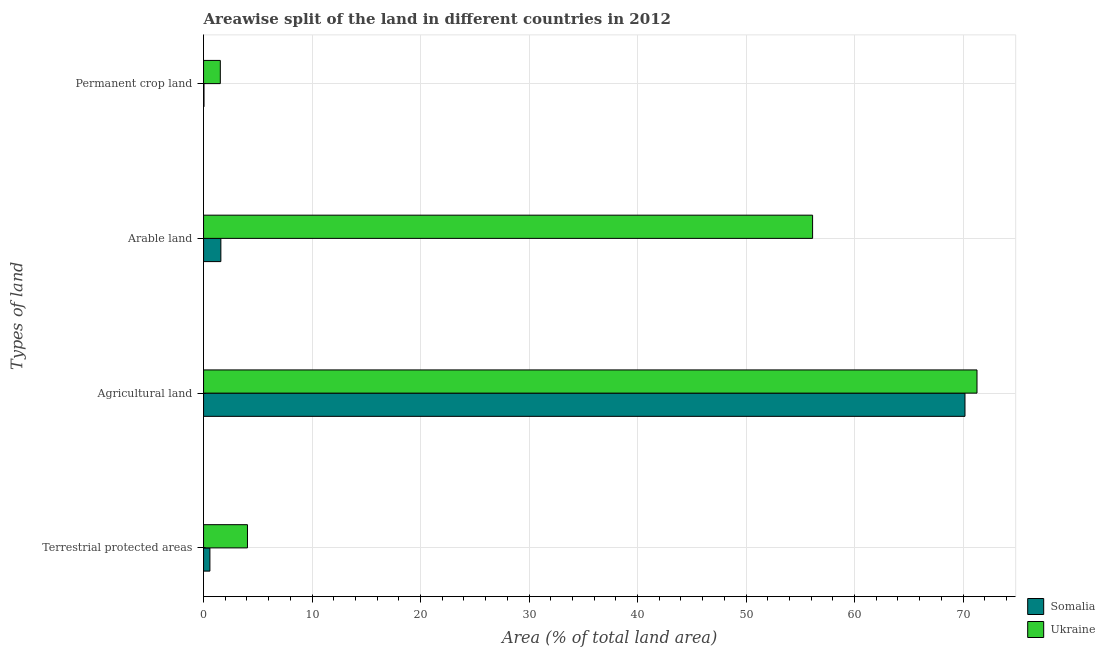How many groups of bars are there?
Your answer should be compact. 4. How many bars are there on the 1st tick from the top?
Make the answer very short. 2. What is the label of the 3rd group of bars from the top?
Keep it short and to the point. Agricultural land. What is the percentage of area under permanent crop land in Somalia?
Provide a short and direct response. 0.04. Across all countries, what is the maximum percentage of area under arable land?
Your response must be concise. 56.13. Across all countries, what is the minimum percentage of area under permanent crop land?
Provide a short and direct response. 0.04. In which country was the percentage of land under terrestrial protection maximum?
Give a very brief answer. Ukraine. In which country was the percentage of area under permanent crop land minimum?
Provide a succinct answer. Somalia. What is the total percentage of area under permanent crop land in the graph?
Provide a short and direct response. 1.58. What is the difference between the percentage of area under arable land in Ukraine and that in Somalia?
Your answer should be compact. 54.54. What is the difference between the percentage of area under agricultural land in Somalia and the percentage of area under permanent crop land in Ukraine?
Offer a terse response. 68.63. What is the average percentage of area under agricultural land per country?
Keep it short and to the point. 70.73. What is the difference between the percentage of area under permanent crop land and percentage of land under terrestrial protection in Somalia?
Offer a very short reply. -0.54. What is the ratio of the percentage of area under permanent crop land in Ukraine to that in Somalia?
Offer a very short reply. 38.72. Is the percentage of area under arable land in Ukraine less than that in Somalia?
Provide a succinct answer. No. What is the difference between the highest and the second highest percentage of land under terrestrial protection?
Give a very brief answer. 3.46. What is the difference between the highest and the lowest percentage of area under agricultural land?
Provide a short and direct response. 1.11. Is the sum of the percentage of area under agricultural land in Somalia and Ukraine greater than the maximum percentage of land under terrestrial protection across all countries?
Make the answer very short. Yes. Is it the case that in every country, the sum of the percentage of area under arable land and percentage of land under terrestrial protection is greater than the sum of percentage of area under permanent crop land and percentage of area under agricultural land?
Offer a terse response. Yes. What does the 2nd bar from the top in Permanent crop land represents?
Your response must be concise. Somalia. What does the 2nd bar from the bottom in Terrestrial protected areas represents?
Offer a terse response. Ukraine. Is it the case that in every country, the sum of the percentage of land under terrestrial protection and percentage of area under agricultural land is greater than the percentage of area under arable land?
Your response must be concise. Yes. How many countries are there in the graph?
Your answer should be very brief. 2. What is the difference between two consecutive major ticks on the X-axis?
Offer a terse response. 10. Are the values on the major ticks of X-axis written in scientific E-notation?
Keep it short and to the point. No. Does the graph contain grids?
Keep it short and to the point. Yes. Where does the legend appear in the graph?
Give a very brief answer. Bottom right. How are the legend labels stacked?
Keep it short and to the point. Vertical. What is the title of the graph?
Provide a short and direct response. Areawise split of the land in different countries in 2012. What is the label or title of the X-axis?
Your answer should be compact. Area (% of total land area). What is the label or title of the Y-axis?
Provide a succinct answer. Types of land. What is the Area (% of total land area) in Somalia in Terrestrial protected areas?
Your answer should be very brief. 0.58. What is the Area (% of total land area) of Ukraine in Terrestrial protected areas?
Your response must be concise. 4.05. What is the Area (% of total land area) of Somalia in Agricultural land?
Your response must be concise. 70.18. What is the Area (% of total land area) of Ukraine in Agricultural land?
Make the answer very short. 71.29. What is the Area (% of total land area) of Somalia in Arable land?
Your response must be concise. 1.59. What is the Area (% of total land area) of Ukraine in Arable land?
Your answer should be compact. 56.13. What is the Area (% of total land area) in Somalia in Permanent crop land?
Offer a terse response. 0.04. What is the Area (% of total land area) in Ukraine in Permanent crop land?
Your answer should be compact. 1.54. Across all Types of land, what is the maximum Area (% of total land area) of Somalia?
Your answer should be very brief. 70.18. Across all Types of land, what is the maximum Area (% of total land area) of Ukraine?
Ensure brevity in your answer.  71.29. Across all Types of land, what is the minimum Area (% of total land area) of Somalia?
Give a very brief answer. 0.04. Across all Types of land, what is the minimum Area (% of total land area) in Ukraine?
Offer a terse response. 1.54. What is the total Area (% of total land area) of Somalia in the graph?
Ensure brevity in your answer.  72.4. What is the total Area (% of total land area) of Ukraine in the graph?
Ensure brevity in your answer.  133.01. What is the difference between the Area (% of total land area) in Somalia in Terrestrial protected areas and that in Agricultural land?
Give a very brief answer. -69.59. What is the difference between the Area (% of total land area) of Ukraine in Terrestrial protected areas and that in Agricultural land?
Your answer should be compact. -67.24. What is the difference between the Area (% of total land area) in Somalia in Terrestrial protected areas and that in Arable land?
Offer a very short reply. -1.01. What is the difference between the Area (% of total land area) of Ukraine in Terrestrial protected areas and that in Arable land?
Your response must be concise. -52.08. What is the difference between the Area (% of total land area) of Somalia in Terrestrial protected areas and that in Permanent crop land?
Ensure brevity in your answer.  0.54. What is the difference between the Area (% of total land area) in Ukraine in Terrestrial protected areas and that in Permanent crop land?
Your answer should be very brief. 2.5. What is the difference between the Area (% of total land area) of Somalia in Agricultural land and that in Arable land?
Provide a succinct answer. 68.58. What is the difference between the Area (% of total land area) in Ukraine in Agricultural land and that in Arable land?
Offer a terse response. 15.15. What is the difference between the Area (% of total land area) of Somalia in Agricultural land and that in Permanent crop land?
Your response must be concise. 70.14. What is the difference between the Area (% of total land area) of Ukraine in Agricultural land and that in Permanent crop land?
Keep it short and to the point. 69.74. What is the difference between the Area (% of total land area) of Somalia in Arable land and that in Permanent crop land?
Give a very brief answer. 1.55. What is the difference between the Area (% of total land area) of Ukraine in Arable land and that in Permanent crop land?
Give a very brief answer. 54.59. What is the difference between the Area (% of total land area) in Somalia in Terrestrial protected areas and the Area (% of total land area) in Ukraine in Agricultural land?
Your answer should be very brief. -70.7. What is the difference between the Area (% of total land area) of Somalia in Terrestrial protected areas and the Area (% of total land area) of Ukraine in Arable land?
Make the answer very short. -55.55. What is the difference between the Area (% of total land area) of Somalia in Terrestrial protected areas and the Area (% of total land area) of Ukraine in Permanent crop land?
Your answer should be very brief. -0.96. What is the difference between the Area (% of total land area) of Somalia in Agricultural land and the Area (% of total land area) of Ukraine in Arable land?
Keep it short and to the point. 14.05. What is the difference between the Area (% of total land area) of Somalia in Agricultural land and the Area (% of total land area) of Ukraine in Permanent crop land?
Your answer should be compact. 68.63. What is the difference between the Area (% of total land area) of Somalia in Arable land and the Area (% of total land area) of Ukraine in Permanent crop land?
Provide a short and direct response. 0.05. What is the average Area (% of total land area) in Somalia per Types of land?
Offer a terse response. 18.1. What is the average Area (% of total land area) in Ukraine per Types of land?
Keep it short and to the point. 33.25. What is the difference between the Area (% of total land area) in Somalia and Area (% of total land area) in Ukraine in Terrestrial protected areas?
Keep it short and to the point. -3.46. What is the difference between the Area (% of total land area) in Somalia and Area (% of total land area) in Ukraine in Agricultural land?
Your answer should be very brief. -1.11. What is the difference between the Area (% of total land area) of Somalia and Area (% of total land area) of Ukraine in Arable land?
Make the answer very short. -54.54. What is the difference between the Area (% of total land area) in Somalia and Area (% of total land area) in Ukraine in Permanent crop land?
Your answer should be compact. -1.5. What is the ratio of the Area (% of total land area) of Somalia in Terrestrial protected areas to that in Agricultural land?
Provide a short and direct response. 0.01. What is the ratio of the Area (% of total land area) of Ukraine in Terrestrial protected areas to that in Agricultural land?
Your answer should be very brief. 0.06. What is the ratio of the Area (% of total land area) of Somalia in Terrestrial protected areas to that in Arable land?
Ensure brevity in your answer.  0.37. What is the ratio of the Area (% of total land area) of Ukraine in Terrestrial protected areas to that in Arable land?
Your answer should be very brief. 0.07. What is the ratio of the Area (% of total land area) of Somalia in Terrestrial protected areas to that in Permanent crop land?
Provide a short and direct response. 14.65. What is the ratio of the Area (% of total land area) in Ukraine in Terrestrial protected areas to that in Permanent crop land?
Provide a short and direct response. 2.62. What is the ratio of the Area (% of total land area) of Somalia in Agricultural land to that in Arable land?
Keep it short and to the point. 44.02. What is the ratio of the Area (% of total land area) in Ukraine in Agricultural land to that in Arable land?
Give a very brief answer. 1.27. What is the ratio of the Area (% of total land area) of Somalia in Agricultural land to that in Permanent crop land?
Offer a very short reply. 1761. What is the ratio of the Area (% of total land area) of Ukraine in Agricultural land to that in Permanent crop land?
Give a very brief answer. 46.19. What is the ratio of the Area (% of total land area) of Somalia in Arable land to that in Permanent crop land?
Provide a succinct answer. 40. What is the ratio of the Area (% of total land area) of Ukraine in Arable land to that in Permanent crop land?
Ensure brevity in your answer.  36.37. What is the difference between the highest and the second highest Area (% of total land area) in Somalia?
Offer a terse response. 68.58. What is the difference between the highest and the second highest Area (% of total land area) of Ukraine?
Ensure brevity in your answer.  15.15. What is the difference between the highest and the lowest Area (% of total land area) of Somalia?
Offer a terse response. 70.14. What is the difference between the highest and the lowest Area (% of total land area) in Ukraine?
Your answer should be very brief. 69.74. 